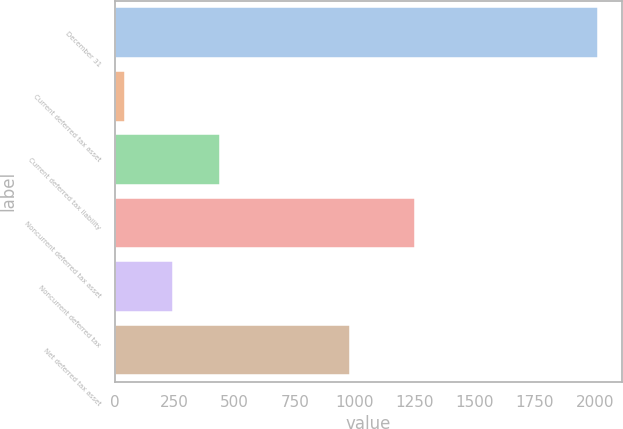Convert chart. <chart><loc_0><loc_0><loc_500><loc_500><bar_chart><fcel>December 31<fcel>Current deferred tax asset<fcel>Current deferred tax liability<fcel>Noncurrent deferred tax asset<fcel>Noncurrent deferred tax<fcel>Net deferred tax asset<nl><fcel>2012<fcel>44<fcel>437.6<fcel>1251<fcel>240.8<fcel>978<nl></chart> 